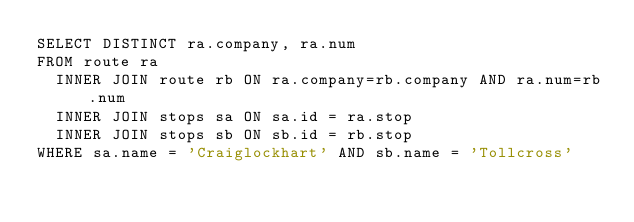Convert code to text. <code><loc_0><loc_0><loc_500><loc_500><_SQL_>SELECT DISTINCT ra.company, ra.num
FROM route ra 
  INNER JOIN route rb ON ra.company=rb.company AND ra.num=rb.num
  INNER JOIN stops sa ON sa.id = ra.stop
  INNER JOIN stops sb ON sb.id = rb.stop
WHERE sa.name = 'Craiglockhart' AND sb.name = 'Tollcross'</code> 